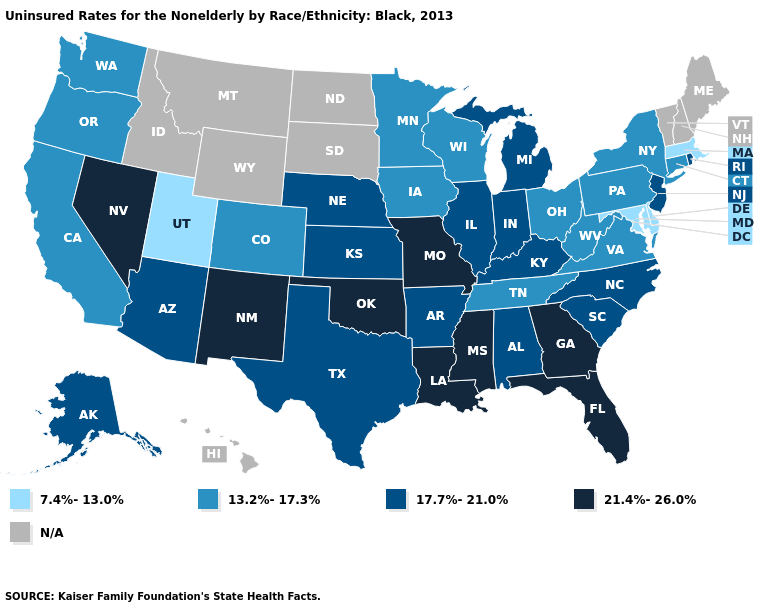Does Delaware have the lowest value in the USA?
Be succinct. Yes. What is the value of New York?
Answer briefly. 13.2%-17.3%. What is the highest value in the West ?
Short answer required. 21.4%-26.0%. Name the states that have a value in the range N/A?
Concise answer only. Hawaii, Idaho, Maine, Montana, New Hampshire, North Dakota, South Dakota, Vermont, Wyoming. Name the states that have a value in the range 21.4%-26.0%?
Answer briefly. Florida, Georgia, Louisiana, Mississippi, Missouri, Nevada, New Mexico, Oklahoma. Which states have the lowest value in the USA?
Give a very brief answer. Delaware, Maryland, Massachusetts, Utah. Among the states that border Utah , which have the highest value?
Short answer required. Nevada, New Mexico. What is the highest value in the USA?
Give a very brief answer. 21.4%-26.0%. What is the value of Minnesota?
Quick response, please. 13.2%-17.3%. Does Pennsylvania have the highest value in the Northeast?
Short answer required. No. Name the states that have a value in the range 17.7%-21.0%?
Concise answer only. Alabama, Alaska, Arizona, Arkansas, Illinois, Indiana, Kansas, Kentucky, Michigan, Nebraska, New Jersey, North Carolina, Rhode Island, South Carolina, Texas. What is the value of Kentucky?
Short answer required. 17.7%-21.0%. What is the value of Kansas?
Keep it brief. 17.7%-21.0%. 